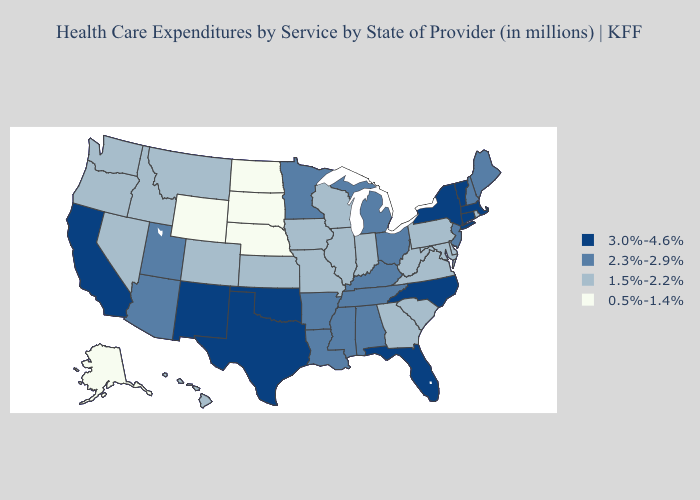Does Indiana have the lowest value in the USA?
Concise answer only. No. Name the states that have a value in the range 3.0%-4.6%?
Write a very short answer. California, Connecticut, Florida, Massachusetts, New Mexico, New York, North Carolina, Oklahoma, Texas, Vermont. Does California have the highest value in the USA?
Short answer required. Yes. Name the states that have a value in the range 2.3%-2.9%?
Give a very brief answer. Alabama, Arizona, Arkansas, Kentucky, Louisiana, Maine, Michigan, Minnesota, Mississippi, New Hampshire, New Jersey, Ohio, Tennessee, Utah. Does Illinois have the highest value in the MidWest?
Keep it brief. No. Does South Carolina have the highest value in the USA?
Quick response, please. No. Among the states that border Nevada , does Arizona have the highest value?
Answer briefly. No. Name the states that have a value in the range 0.5%-1.4%?
Answer briefly. Alaska, Nebraska, North Dakota, South Dakota, Wyoming. What is the value of Vermont?
Give a very brief answer. 3.0%-4.6%. What is the value of Texas?
Short answer required. 3.0%-4.6%. Name the states that have a value in the range 0.5%-1.4%?
Be succinct. Alaska, Nebraska, North Dakota, South Dakota, Wyoming. Does Utah have the highest value in the USA?
Quick response, please. No. What is the highest value in the USA?
Short answer required. 3.0%-4.6%. Among the states that border Idaho , does Nevada have the highest value?
Quick response, please. No. Which states have the lowest value in the USA?
Keep it brief. Alaska, Nebraska, North Dakota, South Dakota, Wyoming. 